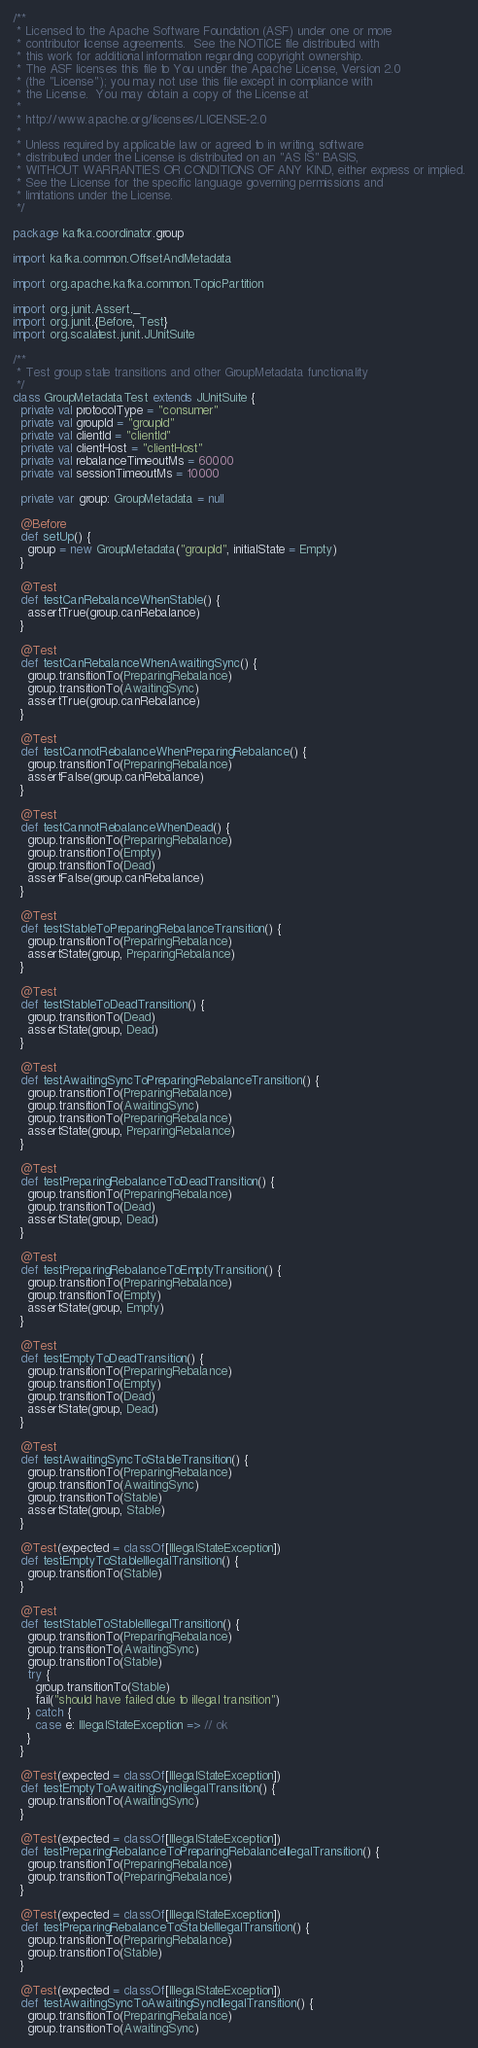<code> <loc_0><loc_0><loc_500><loc_500><_Scala_>/**
 * Licensed to the Apache Software Foundation (ASF) under one or more
 * contributor license agreements.  See the NOTICE file distributed with
 * this work for additional information regarding copyright ownership.
 * The ASF licenses this file to You under the Apache License, Version 2.0
 * (the "License"); you may not use this file except in compliance with
 * the License.  You may obtain a copy of the License at
 *
 * http://www.apache.org/licenses/LICENSE-2.0
 *
 * Unless required by applicable law or agreed to in writing, software
 * distributed under the License is distributed on an "AS IS" BASIS,
 * WITHOUT WARRANTIES OR CONDITIONS OF ANY KIND, either express or implied.
 * See the License for the specific language governing permissions and
 * limitations under the License.
 */

package kafka.coordinator.group

import kafka.common.OffsetAndMetadata

import org.apache.kafka.common.TopicPartition

import org.junit.Assert._
import org.junit.{Before, Test}
import org.scalatest.junit.JUnitSuite

/**
 * Test group state transitions and other GroupMetadata functionality
 */
class GroupMetadataTest extends JUnitSuite {
  private val protocolType = "consumer"
  private val groupId = "groupId"
  private val clientId = "clientId"
  private val clientHost = "clientHost"
  private val rebalanceTimeoutMs = 60000
  private val sessionTimeoutMs = 10000

  private var group: GroupMetadata = null

  @Before
  def setUp() {
    group = new GroupMetadata("groupId", initialState = Empty)
  }

  @Test
  def testCanRebalanceWhenStable() {
    assertTrue(group.canRebalance)
  }

  @Test
  def testCanRebalanceWhenAwaitingSync() {
    group.transitionTo(PreparingRebalance)
    group.transitionTo(AwaitingSync)
    assertTrue(group.canRebalance)
  }

  @Test
  def testCannotRebalanceWhenPreparingRebalance() {
    group.transitionTo(PreparingRebalance)
    assertFalse(group.canRebalance)
  }

  @Test
  def testCannotRebalanceWhenDead() {
    group.transitionTo(PreparingRebalance)
    group.transitionTo(Empty)
    group.transitionTo(Dead)
    assertFalse(group.canRebalance)
  }

  @Test
  def testStableToPreparingRebalanceTransition() {
    group.transitionTo(PreparingRebalance)
    assertState(group, PreparingRebalance)
  }

  @Test
  def testStableToDeadTransition() {
    group.transitionTo(Dead)
    assertState(group, Dead)
  }

  @Test
  def testAwaitingSyncToPreparingRebalanceTransition() {
    group.transitionTo(PreparingRebalance)
    group.transitionTo(AwaitingSync)
    group.transitionTo(PreparingRebalance)
    assertState(group, PreparingRebalance)
  }

  @Test
  def testPreparingRebalanceToDeadTransition() {
    group.transitionTo(PreparingRebalance)
    group.transitionTo(Dead)
    assertState(group, Dead)
  }

  @Test
  def testPreparingRebalanceToEmptyTransition() {
    group.transitionTo(PreparingRebalance)
    group.transitionTo(Empty)
    assertState(group, Empty)
  }

  @Test
  def testEmptyToDeadTransition() {
    group.transitionTo(PreparingRebalance)
    group.transitionTo(Empty)
    group.transitionTo(Dead)
    assertState(group, Dead)
  }

  @Test
  def testAwaitingSyncToStableTransition() {
    group.transitionTo(PreparingRebalance)
    group.transitionTo(AwaitingSync)
    group.transitionTo(Stable)
    assertState(group, Stable)
  }

  @Test(expected = classOf[IllegalStateException])
  def testEmptyToStableIllegalTransition() {
    group.transitionTo(Stable)
  }

  @Test
  def testStableToStableIllegalTransition() {
    group.transitionTo(PreparingRebalance)
    group.transitionTo(AwaitingSync)
    group.transitionTo(Stable)
    try {
      group.transitionTo(Stable)
      fail("should have failed due to illegal transition")
    } catch {
      case e: IllegalStateException => // ok
    }
  }

  @Test(expected = classOf[IllegalStateException])
  def testEmptyToAwaitingSyncIllegalTransition() {
    group.transitionTo(AwaitingSync)
  }

  @Test(expected = classOf[IllegalStateException])
  def testPreparingRebalanceToPreparingRebalanceIllegalTransition() {
    group.transitionTo(PreparingRebalance)
    group.transitionTo(PreparingRebalance)
  }

  @Test(expected = classOf[IllegalStateException])
  def testPreparingRebalanceToStableIllegalTransition() {
    group.transitionTo(PreparingRebalance)
    group.transitionTo(Stable)
  }

  @Test(expected = classOf[IllegalStateException])
  def testAwaitingSyncToAwaitingSyncIllegalTransition() {
    group.transitionTo(PreparingRebalance)
    group.transitionTo(AwaitingSync)</code> 